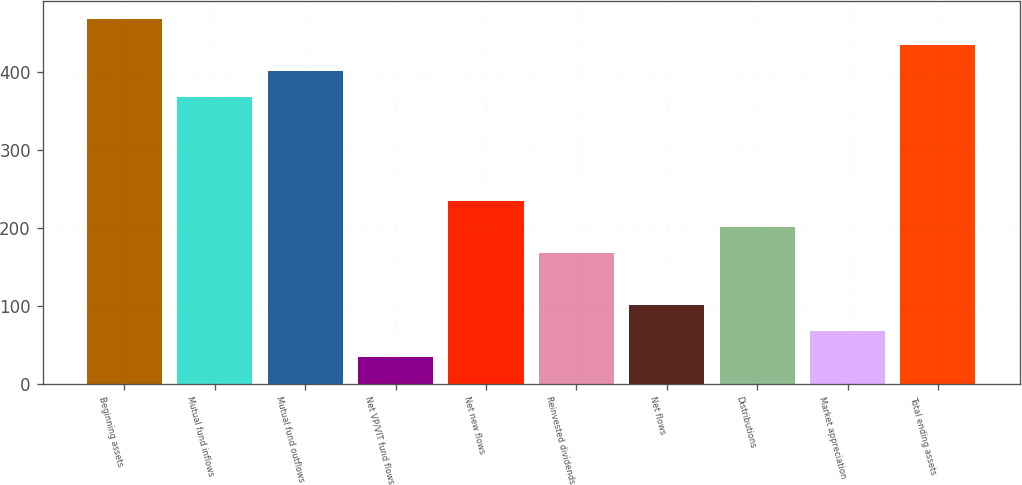<chart> <loc_0><loc_0><loc_500><loc_500><bar_chart><fcel>Beginning assets<fcel>Mutual fund inflows<fcel>Mutual fund outflows<fcel>Net VP/VIT fund flows<fcel>Net new flows<fcel>Reinvested dividends<fcel>Net flows<fcel>Distributions<fcel>Market appreciation<fcel>Total ending assets<nl><fcel>468.34<fcel>368.11<fcel>401.52<fcel>34.01<fcel>234.47<fcel>167.65<fcel>100.83<fcel>201.06<fcel>67.42<fcel>434.93<nl></chart> 